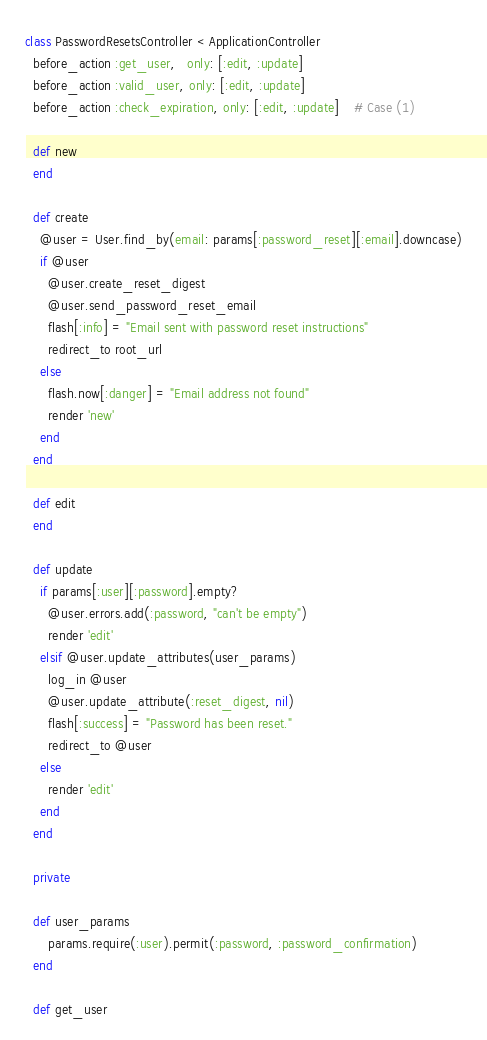<code> <loc_0><loc_0><loc_500><loc_500><_Ruby_>class PasswordResetsController < ApplicationController
  before_action :get_user,   only: [:edit, :update]
  before_action :valid_user, only: [:edit, :update]
  before_action :check_expiration, only: [:edit, :update]    # Case (1)

  def new
  end

  def create
    @user = User.find_by(email: params[:password_reset][:email].downcase)
    if @user
      @user.create_reset_digest
      @user.send_password_reset_email
      flash[:info] = "Email sent with password reset instructions"
      redirect_to root_url
    else
      flash.now[:danger] = "Email address not found"
      render 'new'
    end
  end

  def edit
  end

  def update
    if params[:user][:password].empty?
      @user.errors.add(:password, "can't be empty")
      render 'edit'
    elsif @user.update_attributes(user_params)
      log_in @user
      @user.update_attribute(:reset_digest, nil)
      flash[:success] = "Password has been reset."
      redirect_to @user
    else
      render 'edit'
    end
  end

  private

  def user_params
      params.require(:user).permit(:password, :password_confirmation)
  end

  def get_user</code> 